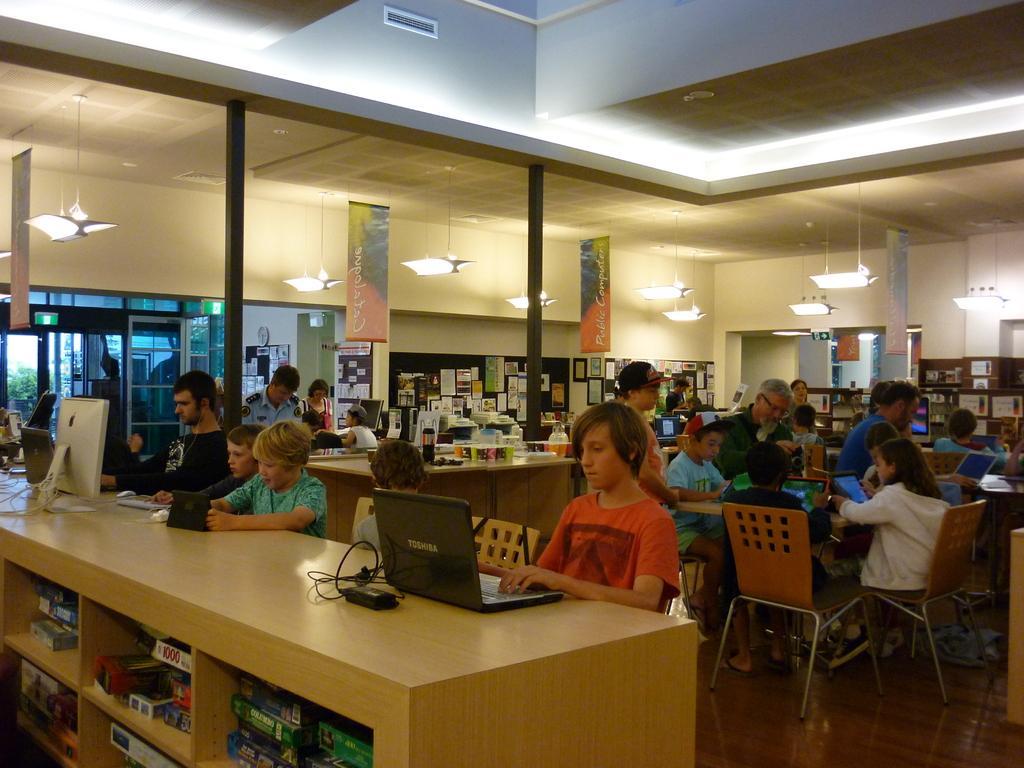Could you give a brief overview of what you see in this image? This image is taken inside a room. There are many people in this room few of them were standing and few of them were sitting on a chairs. In the left side of the image there is a table and on top of it there is a monitor, laptops and few things on it. At the top of the image there is a ceiling with lights. at the background there is a wall with lamps and banners on it. 